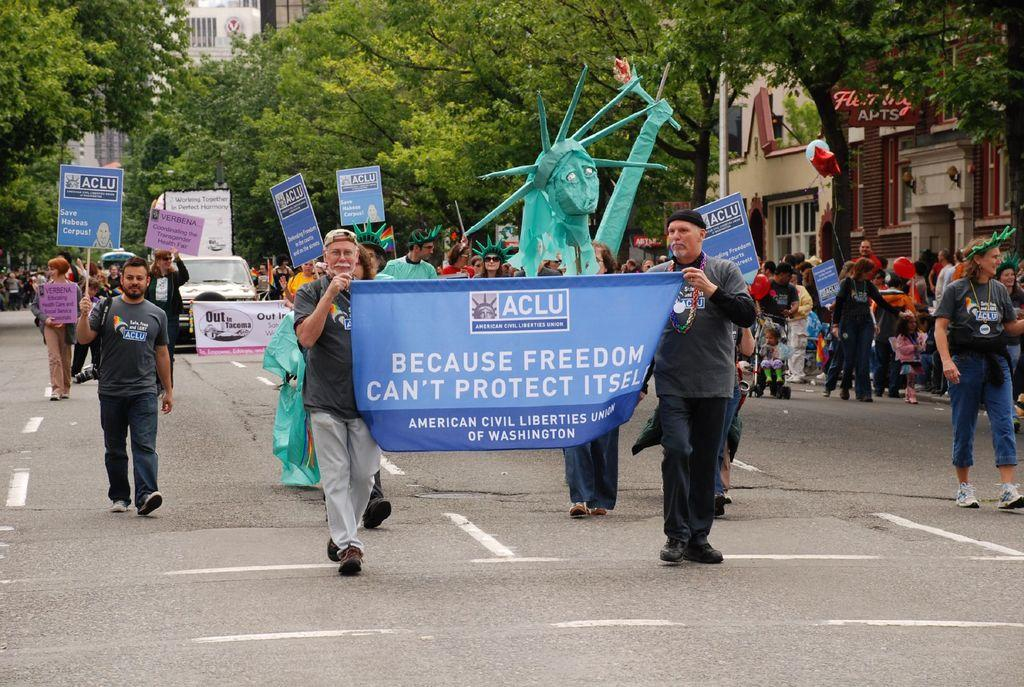What is the main subject in the foreground of the image? There is a crowd in the foreground of the image. Where is the crowd located? The crowd is on the road. What other items can be seen in the foreground of the image? There are boards, posters, and costumes in the foreground of the image. What can be seen in the background of the image? There are buildings, trees, and a pole in the background of the image. What type of property can be seen in the image? There is no property visible in the image; it features a crowd on the road, along with various items and background elements. Can you tell me how many airports are visible in the image? There are no airports present in the image. 